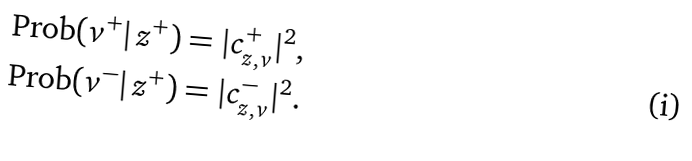<formula> <loc_0><loc_0><loc_500><loc_500>\text {Prob} ( v ^ { + } | \, z ^ { + } ) = | c ^ { + } _ { z , v } | ^ { 2 } , \\ \text {Prob} ( v ^ { - } | \, z ^ { + } ) = | c ^ { - } _ { z , v } | ^ { 2 } .</formula> 